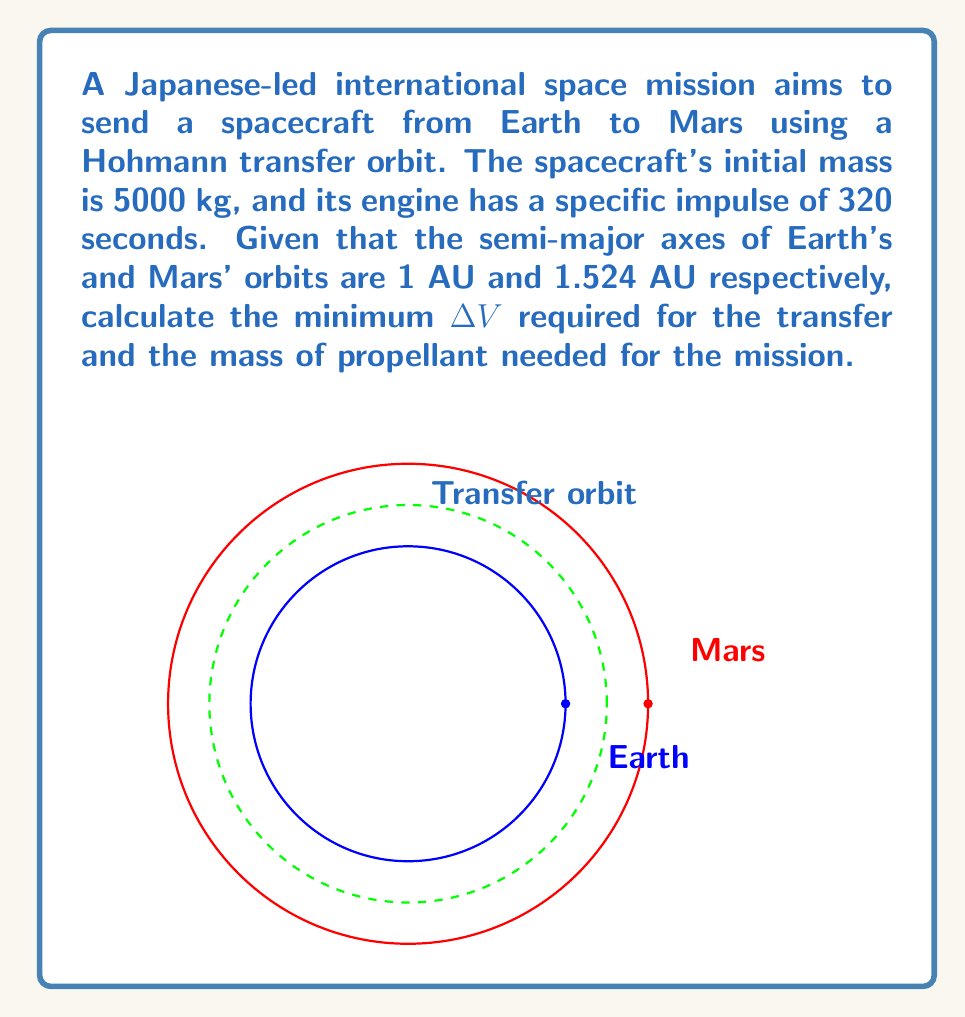Could you help me with this problem? Let's approach this problem step-by-step:

1) The Hohmann transfer orbit is an elliptical orbit that touches both the initial and final circular orbits at its periapsis and apoapsis, respectively.

2) The semi-major axis of the transfer orbit (a_t) is the average of the radii of the two circular orbits:

   $$a_t = \frac{r_1 + r_2}{2} = \frac{1 + 1.524}{2} = 1.262 \text{ AU}$$

3) The velocity of a body in a circular orbit is given by:

   $$v_c = \sqrt{\frac{\mu}{r}}$$

   where μ is the gravitational parameter of the Sun (1.32712440018 × 10^20 m^3/s^2).

4) The velocities at Earth's orbit (v_1) and Mars' orbit (v_2) are:

   $$v_1 = \sqrt{\frac{\mu}{r_1}} = 29.78 \text{ km/s}$$
   $$v_2 = \sqrt{\frac{\mu}{r_2}} = 24.07 \text{ km/s}$$

5) The velocities at periapsis (v_p) and apoapsis (v_a) of the transfer orbit are:

   $$v_p = \sqrt{\mu(\frac{2}{r_1} - \frac{1}{a_t})} = 32.73 \text{ km/s}$$
   $$v_a = \sqrt{\mu(\frac{2}{r_2} - \frac{1}{a_t})} = 21.48 \text{ km/s}$$

6) The total ΔV required is the sum of the two burns:

   $$\Delta V = (v_p - v_1) + (v_2 - v_a) = (32.73 - 29.78) + (24.07 - 21.48) = 5.54 \text{ km/s}$$

7) To calculate the propellant mass, we use the rocket equation:

   $$\Delta V = I_{sp} g_0 \ln(\frac{m_0}{m_f})$$

   where $I_{sp}$ is the specific impulse, $g_0$ is the standard gravity (9.80665 m/s^2), $m_0$ is the initial mass, and $m_f$ is the final mass.

8) Rearranging the equation:

   $$m_f = m_0 e^{-\frac{\Delta V}{I_{sp} g_0}}$$

9) The propellant mass is the difference between initial and final mass:

   $$m_p = m_0 - m_f = 5000 - 5000e^{-\frac{5540}{320 * 9.80665}} = 1635.7 \text{ kg}$$
Answer: ΔV = 5.54 km/s, Propellant mass = 1635.7 kg 